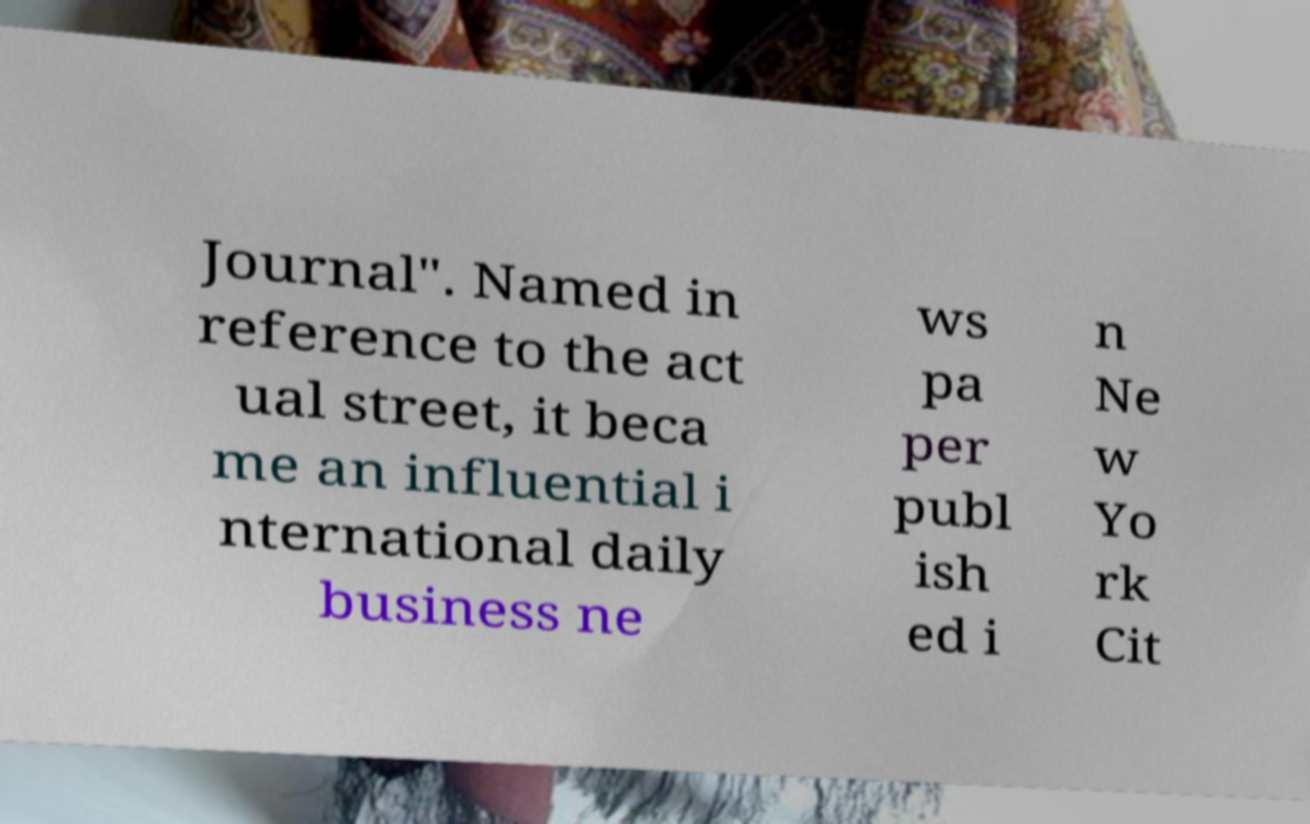I need the written content from this picture converted into text. Can you do that? Journal". Named in reference to the act ual street, it beca me an influential i nternational daily business ne ws pa per publ ish ed i n Ne w Yo rk Cit 